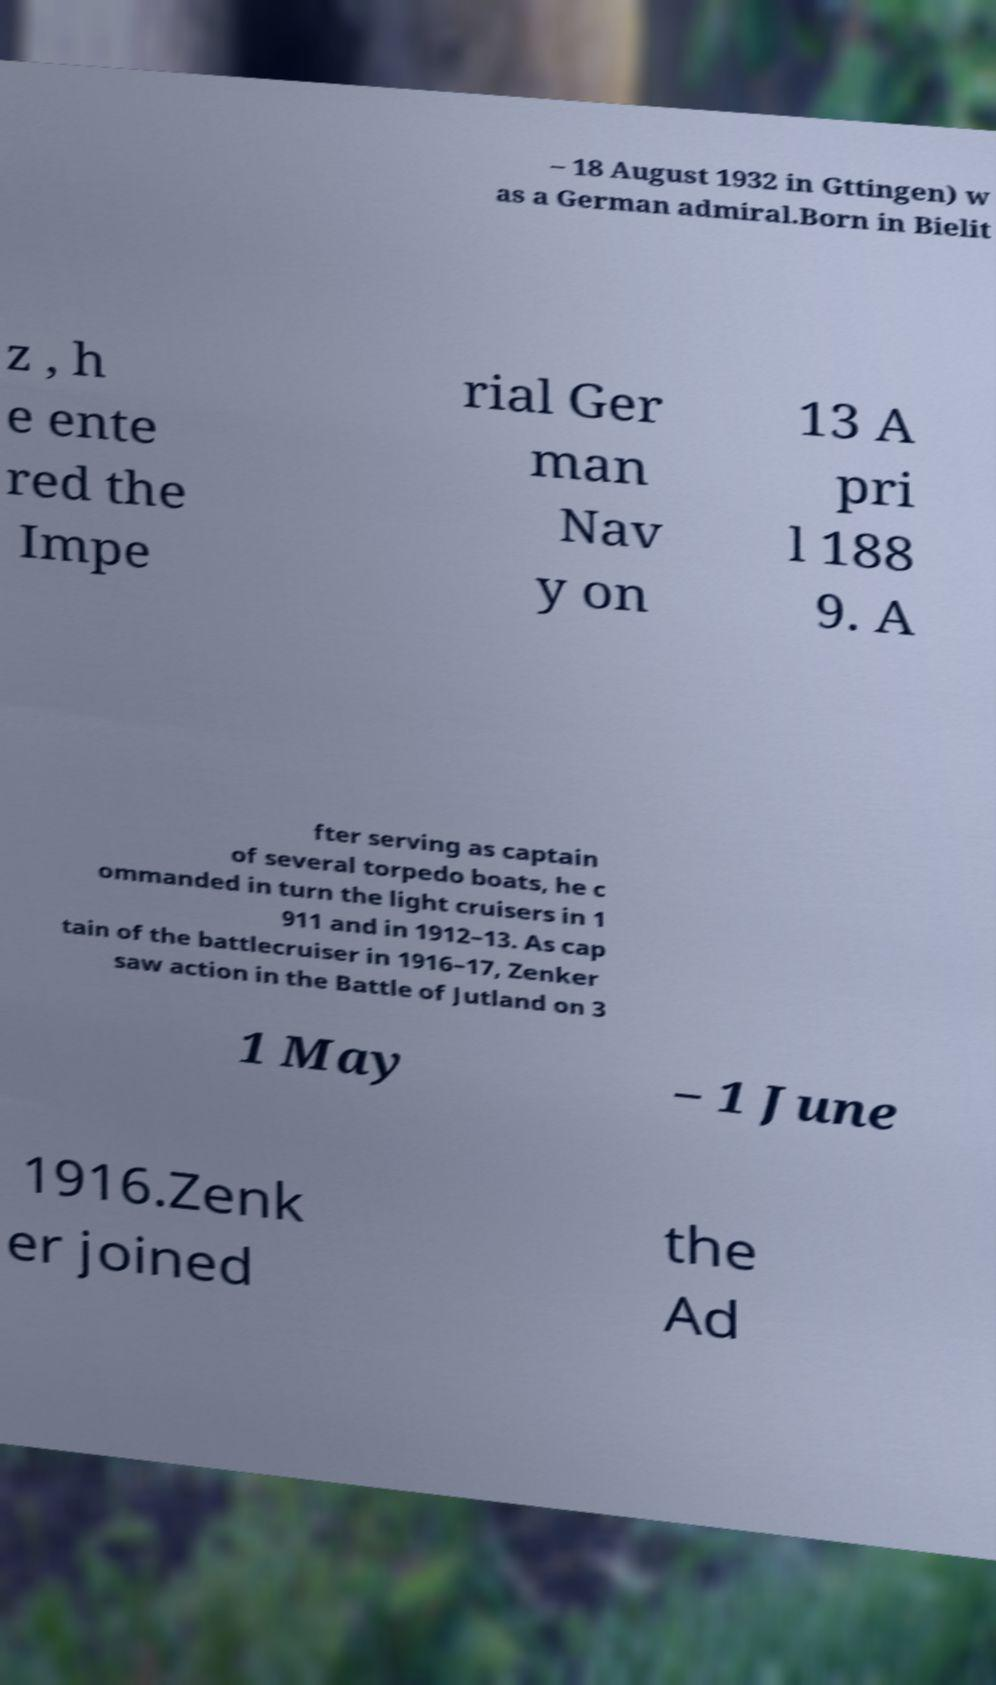Can you read and provide the text displayed in the image?This photo seems to have some interesting text. Can you extract and type it out for me? – 18 August 1932 in Gttingen) w as a German admiral.Born in Bielit z , h e ente red the Impe rial Ger man Nav y on 13 A pri l 188 9. A fter serving as captain of several torpedo boats, he c ommanded in turn the light cruisers in 1 911 and in 1912–13. As cap tain of the battlecruiser in 1916–17, Zenker saw action in the Battle of Jutland on 3 1 May – 1 June 1916.Zenk er joined the Ad 